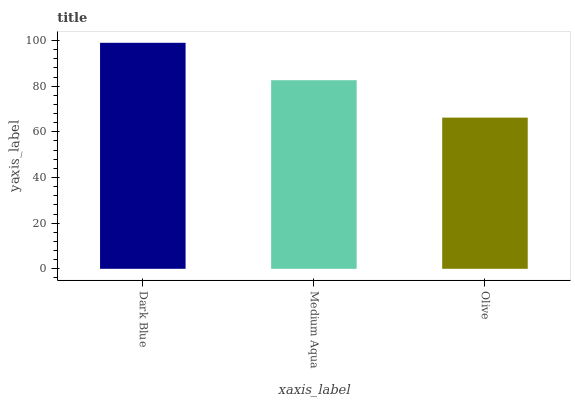Is Olive the minimum?
Answer yes or no. Yes. Is Dark Blue the maximum?
Answer yes or no. Yes. Is Medium Aqua the minimum?
Answer yes or no. No. Is Medium Aqua the maximum?
Answer yes or no. No. Is Dark Blue greater than Medium Aqua?
Answer yes or no. Yes. Is Medium Aqua less than Dark Blue?
Answer yes or no. Yes. Is Medium Aqua greater than Dark Blue?
Answer yes or no. No. Is Dark Blue less than Medium Aqua?
Answer yes or no. No. Is Medium Aqua the high median?
Answer yes or no. Yes. Is Medium Aqua the low median?
Answer yes or no. Yes. Is Olive the high median?
Answer yes or no. No. Is Olive the low median?
Answer yes or no. No. 